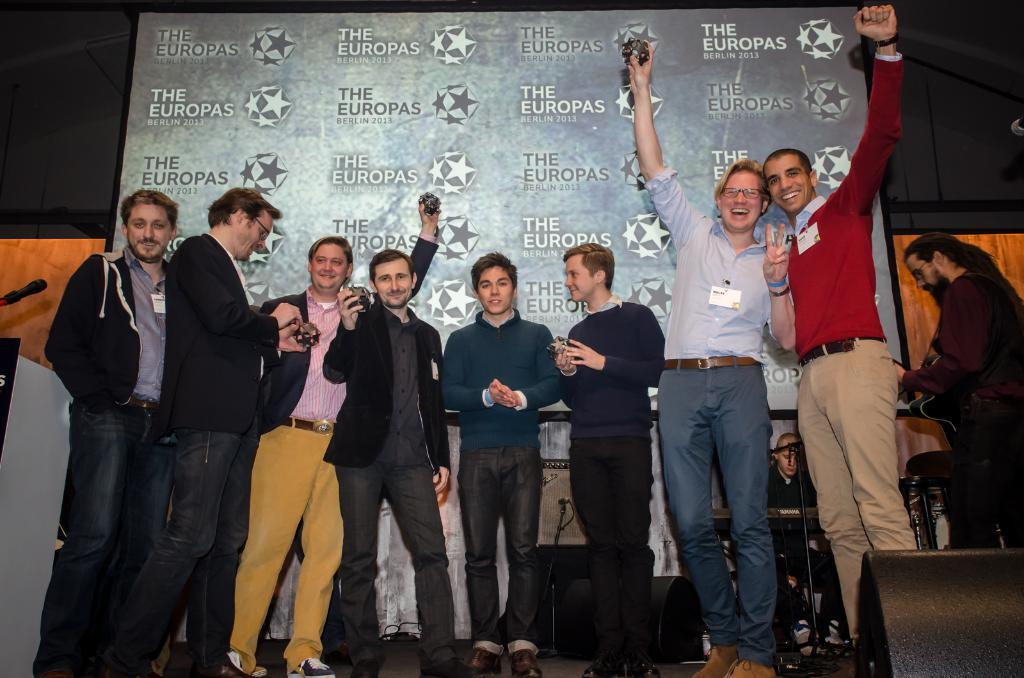How many people are in the image? There is a group of people in the image, but the exact number is not specified. What are the people in the image doing? The people are standing in the image. What are the people holding in the image? The people are holding something, but the specific object is not mentioned. What is the purpose of the podium in the image? The presence of a podium suggests that it might be used for presentations or speeches. What is the microphone used for in the image? The microphone is likely used for amplifying sound during speeches or presentations. What type of objects are the musical instruments in the image? The presence of musical instruments suggests that there might be a performance or musical event taking place. What are the boards used for in the image? The boards might be used for displaying information, such as posters or signs. What is displayed on the screen in the image? The screen might be displaying visual aids, such as slides or videos, to support the presentation or performance. Can you describe the other objects in the image? The other objects in the image are not specified, so it is not possible to describe them. How many pins are attached to the class in the image? There is no mention of a class or pins in the image. What type of parcel is being delivered to the people in the image? There is no mention of a parcel or delivery in the image. 